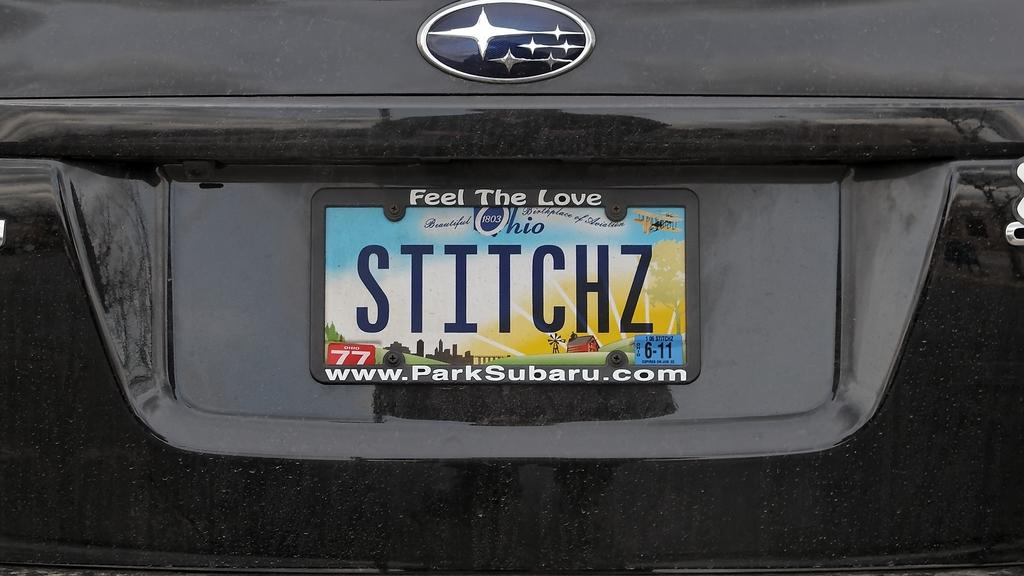What state does this license plate come from?
Make the answer very short. Ohio. 